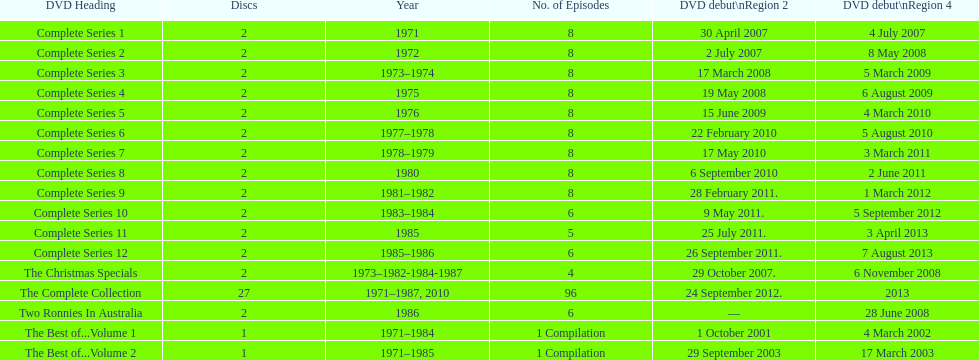The television show "the two ronnies" ran for a total of how many seasons? 12. 